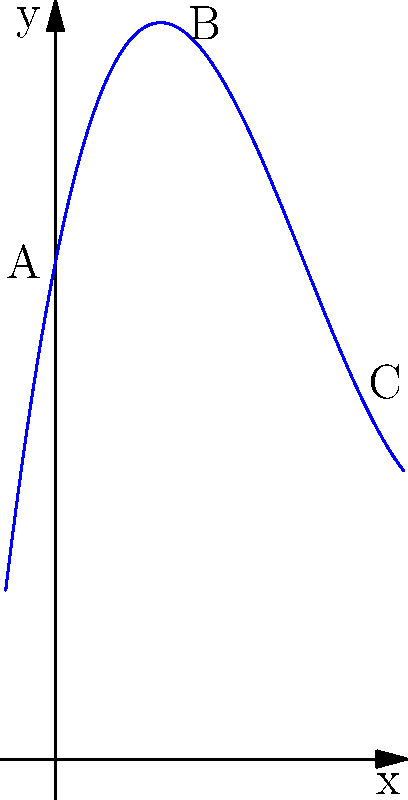In designing terrain for our open-world game, we're using polynomial functions to create realistic elevation profiles. The graph above represents a section of terrain where $y$ represents elevation and $x$ represents horizontal distance. The function is given by $f(x) = 0.1x^3 - 1.5x^2 + 5x + 10$. What is the change in elevation between points A and C? To find the change in elevation between points A and C, we need to:

1. Calculate the elevation at point A (x = 0):
   $f(0) = 0.1(0)^3 - 1.5(0)^2 + 5(0) + 10 = 10$

2. Calculate the elevation at point C (x = 6):
   $f(6) = 0.1(6)^3 - 1.5(6)^2 + 5(6) + 10$
   $    = 21.6 - 54 + 30 + 10 = 7.6$

3. Calculate the difference between these elevations:
   Change in elevation = $f(6) - f(0) = 7.6 - 10 = -2.4$

The negative value indicates that the elevation decreases from A to C.
Answer: -2.4 units 